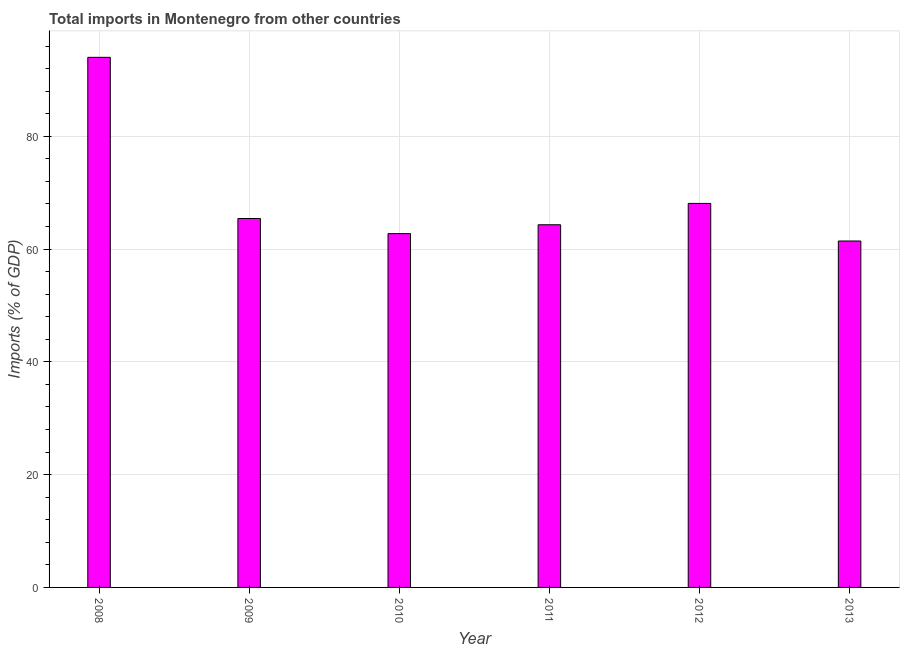Does the graph contain any zero values?
Give a very brief answer. No. What is the title of the graph?
Keep it short and to the point. Total imports in Montenegro from other countries. What is the label or title of the Y-axis?
Provide a short and direct response. Imports (% of GDP). What is the total imports in 2009?
Give a very brief answer. 65.42. Across all years, what is the maximum total imports?
Make the answer very short. 94. Across all years, what is the minimum total imports?
Keep it short and to the point. 61.43. In which year was the total imports maximum?
Offer a very short reply. 2008. In which year was the total imports minimum?
Offer a very short reply. 2013. What is the sum of the total imports?
Give a very brief answer. 415.99. What is the difference between the total imports in 2011 and 2012?
Your response must be concise. -3.78. What is the average total imports per year?
Your response must be concise. 69.33. What is the median total imports?
Your response must be concise. 64.86. In how many years, is the total imports greater than 12 %?
Your answer should be very brief. 6. Do a majority of the years between 2009 and 2012 (inclusive) have total imports greater than 92 %?
Make the answer very short. No. What is the ratio of the total imports in 2009 to that in 2010?
Offer a very short reply. 1.04. Is the difference between the total imports in 2010 and 2013 greater than the difference between any two years?
Your response must be concise. No. What is the difference between the highest and the second highest total imports?
Ensure brevity in your answer.  25.91. What is the difference between the highest and the lowest total imports?
Your answer should be compact. 32.57. How many bars are there?
Your answer should be very brief. 6. Are all the bars in the graph horizontal?
Offer a very short reply. No. What is the Imports (% of GDP) in 2008?
Your answer should be very brief. 94. What is the Imports (% of GDP) of 2009?
Offer a very short reply. 65.42. What is the Imports (% of GDP) of 2010?
Ensure brevity in your answer.  62.74. What is the Imports (% of GDP) in 2011?
Your response must be concise. 64.31. What is the Imports (% of GDP) of 2012?
Your response must be concise. 68.09. What is the Imports (% of GDP) in 2013?
Provide a succinct answer. 61.43. What is the difference between the Imports (% of GDP) in 2008 and 2009?
Your answer should be compact. 28.58. What is the difference between the Imports (% of GDP) in 2008 and 2010?
Your answer should be compact. 31.26. What is the difference between the Imports (% of GDP) in 2008 and 2011?
Offer a terse response. 29.69. What is the difference between the Imports (% of GDP) in 2008 and 2012?
Your answer should be very brief. 25.91. What is the difference between the Imports (% of GDP) in 2008 and 2013?
Provide a short and direct response. 32.57. What is the difference between the Imports (% of GDP) in 2009 and 2010?
Ensure brevity in your answer.  2.68. What is the difference between the Imports (% of GDP) in 2009 and 2011?
Provide a succinct answer. 1.11. What is the difference between the Imports (% of GDP) in 2009 and 2012?
Ensure brevity in your answer.  -2.67. What is the difference between the Imports (% of GDP) in 2009 and 2013?
Provide a short and direct response. 3.99. What is the difference between the Imports (% of GDP) in 2010 and 2011?
Your answer should be compact. -1.57. What is the difference between the Imports (% of GDP) in 2010 and 2012?
Your answer should be compact. -5.36. What is the difference between the Imports (% of GDP) in 2010 and 2013?
Your answer should be compact. 1.31. What is the difference between the Imports (% of GDP) in 2011 and 2012?
Your answer should be very brief. -3.78. What is the difference between the Imports (% of GDP) in 2011 and 2013?
Provide a short and direct response. 2.88. What is the difference between the Imports (% of GDP) in 2012 and 2013?
Offer a terse response. 6.66. What is the ratio of the Imports (% of GDP) in 2008 to that in 2009?
Keep it short and to the point. 1.44. What is the ratio of the Imports (% of GDP) in 2008 to that in 2010?
Give a very brief answer. 1.5. What is the ratio of the Imports (% of GDP) in 2008 to that in 2011?
Make the answer very short. 1.46. What is the ratio of the Imports (% of GDP) in 2008 to that in 2012?
Make the answer very short. 1.38. What is the ratio of the Imports (% of GDP) in 2008 to that in 2013?
Keep it short and to the point. 1.53. What is the ratio of the Imports (% of GDP) in 2009 to that in 2010?
Your answer should be compact. 1.04. What is the ratio of the Imports (% of GDP) in 2009 to that in 2012?
Provide a succinct answer. 0.96. What is the ratio of the Imports (% of GDP) in 2009 to that in 2013?
Your answer should be very brief. 1.06. What is the ratio of the Imports (% of GDP) in 2010 to that in 2011?
Your response must be concise. 0.98. What is the ratio of the Imports (% of GDP) in 2010 to that in 2012?
Your response must be concise. 0.92. What is the ratio of the Imports (% of GDP) in 2010 to that in 2013?
Provide a succinct answer. 1.02. What is the ratio of the Imports (% of GDP) in 2011 to that in 2012?
Your answer should be very brief. 0.94. What is the ratio of the Imports (% of GDP) in 2011 to that in 2013?
Ensure brevity in your answer.  1.05. What is the ratio of the Imports (% of GDP) in 2012 to that in 2013?
Ensure brevity in your answer.  1.11. 